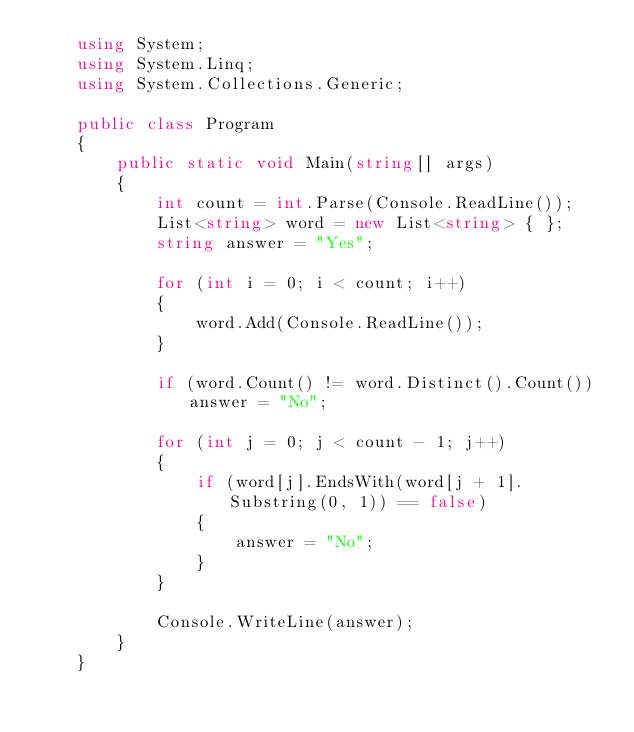<code> <loc_0><loc_0><loc_500><loc_500><_C#_>    using System;
    using System.Linq;
    using System.Collections.Generic;

    public class Program
    {
        public static void Main(string[] args)
        {
            int count = int.Parse(Console.ReadLine());
            List<string> word = new List<string> { };
            string answer = "Yes";

            for (int i = 0; i < count; i++)
            {
                word.Add(Console.ReadLine());
            }

            if (word.Count() != word.Distinct().Count()) answer = "No";

            for (int j = 0; j < count - 1; j++)
            {
                if (word[j].EndsWith(word[j + 1].Substring(0, 1)) == false)
                {
                    answer = "No";
                }
            }

            Console.WriteLine(answer);
        }
    }</code> 